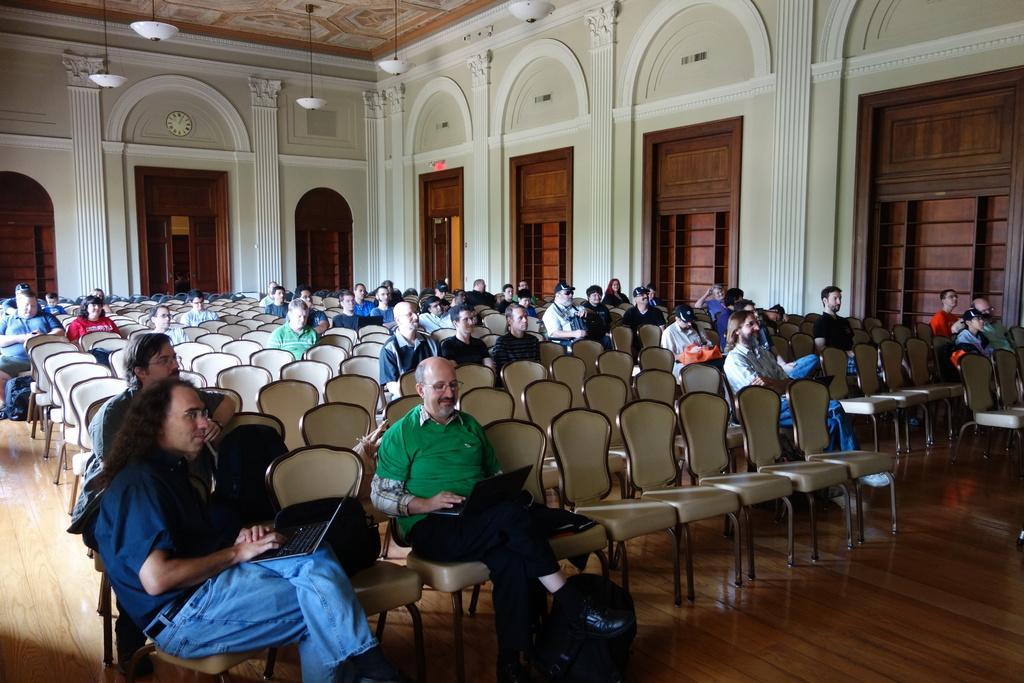Can you describe this image briefly? Here men and women are sitting on the chair, these are windows and this is wall. 